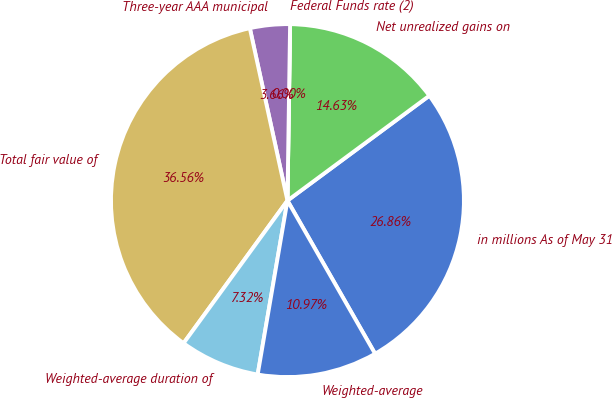<chart> <loc_0><loc_0><loc_500><loc_500><pie_chart><fcel>in millions As of May 31<fcel>Net unrealized gains on<fcel>Federal Funds rate (2)<fcel>Three-year AAA municipal<fcel>Total fair value of<fcel>Weighted-average duration of<fcel>Weighted-average<nl><fcel>26.86%<fcel>14.63%<fcel>0.0%<fcel>3.66%<fcel>36.56%<fcel>7.32%<fcel>10.97%<nl></chart> 